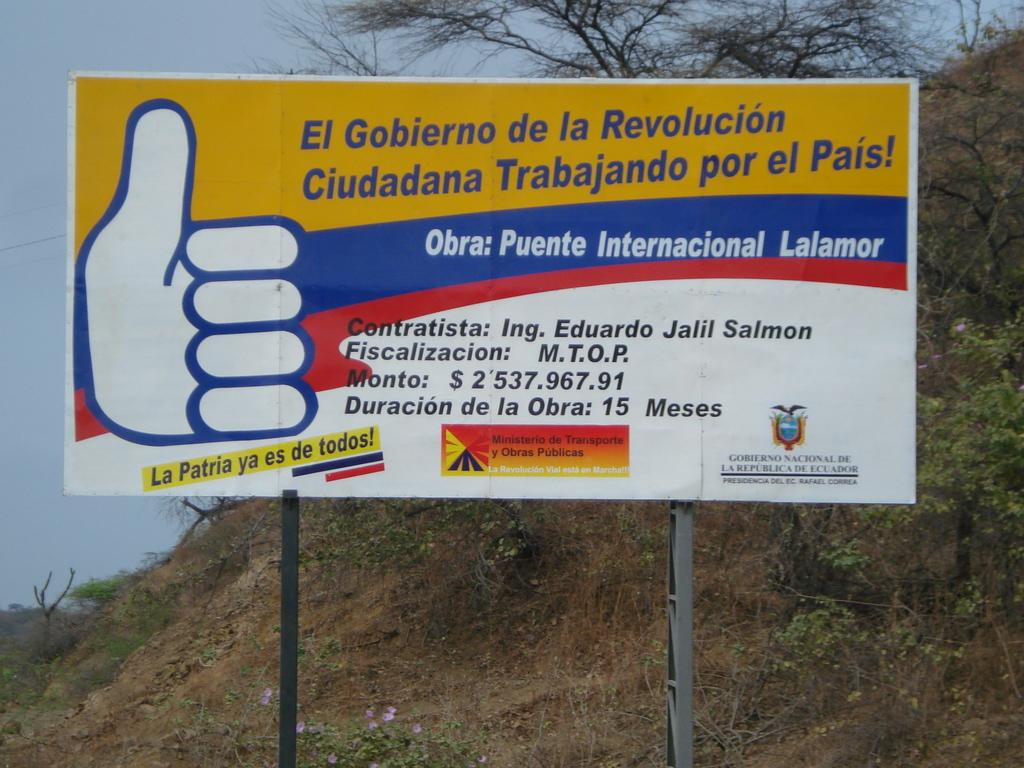<image>
Share a concise interpretation of the image provided. A billboard written in Spanish, with a blue thumbs up 